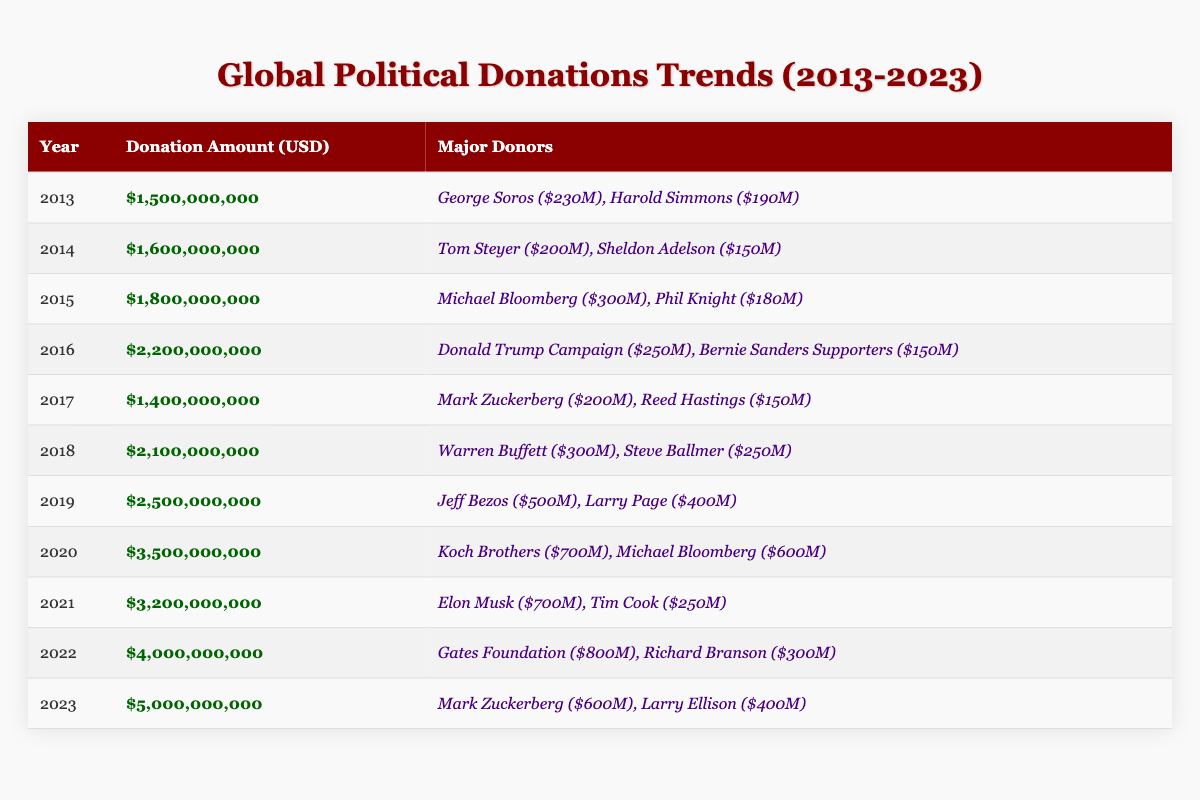What was the total donation amount in 2020? The table shows that the donation amount for the year 2020 is $3,500,000,000.
Answer: $3,500,000,000 Who were the major donors in 2016? According to the table, the major donors in 2016 were Donald Trump Campaign ($250M) and Bernie Sanders Supporters ($150M).
Answer: Donald Trump Campaign ($250M), Bernie Sanders Supporters ($150M) What is the average donation amount over the last decade? To calculate the average, sum the donation amounts from each year from 2013 to 2023: 1.5B + 1.6B + 1.8B + 2.2B + 1.4B + 2.1B + 2.5B + 3.5B + 3.2B + 4B + 5B = 25.4B. There are 11 years, so the average is 25.4B / 11 ≈ 2.309B.
Answer: Approximately $2.309 billion Did the donation amount in 2022 exceed $4 billion? The table specifies the donation amount for 2022 is $4,000,000,000, which equals $4 billion, thus not exceeding it.
Answer: No Which year saw the highest total donations and what was the amount? By examining the table, 2023 had the highest total donations of $5,000,000,000.
Answer: $5,000,000,000 What was the difference in donation amounts between 2013 and 2023? The donation amount in 2013 was $1,500,000,000 and in 2023 it was $5,000,000,000. The difference is $5 billion - $1.5 billion = $3.5 billion.
Answer: $3,500,000,000 In how many years did Mark Zuckerberg appear as a major donor? Mark Zuckerberg is listed as a major donor in 2016 ($200M) and 2023 ($600M), which means he appears twice.
Answer: 2 What was the total amount donated by the Koch Brothers and Michael Bloomberg in 2020? According to the table, the Koch Brothers donated $700,000,000 and Michael Bloomberg donated $600,000,000 in 2020. The total is $700M + $600M = $1.3 billion.
Answer: $1,300,000,000 